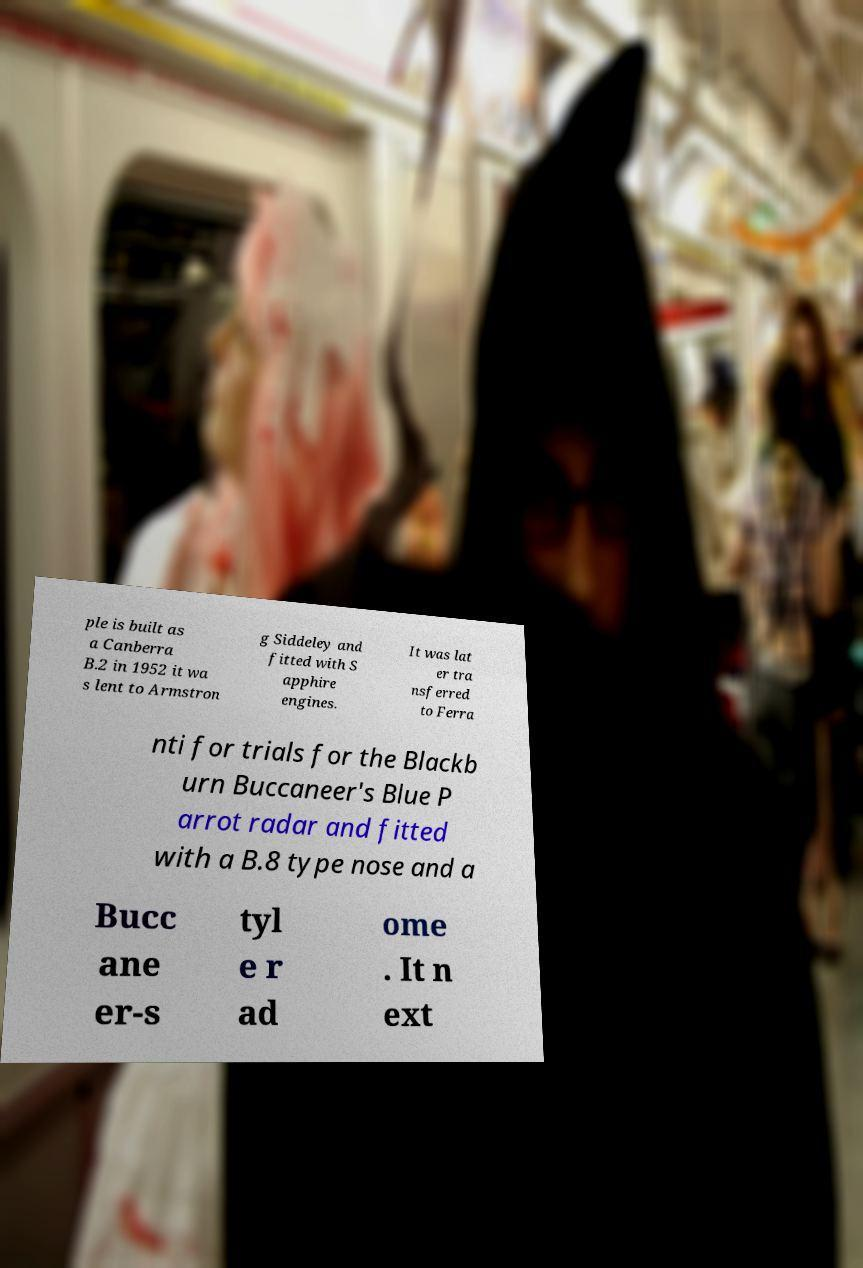Can you accurately transcribe the text from the provided image for me? ple is built as a Canberra B.2 in 1952 it wa s lent to Armstron g Siddeley and fitted with S apphire engines. It was lat er tra nsferred to Ferra nti for trials for the Blackb urn Buccaneer's Blue P arrot radar and fitted with a B.8 type nose and a Bucc ane er-s tyl e r ad ome . It n ext 